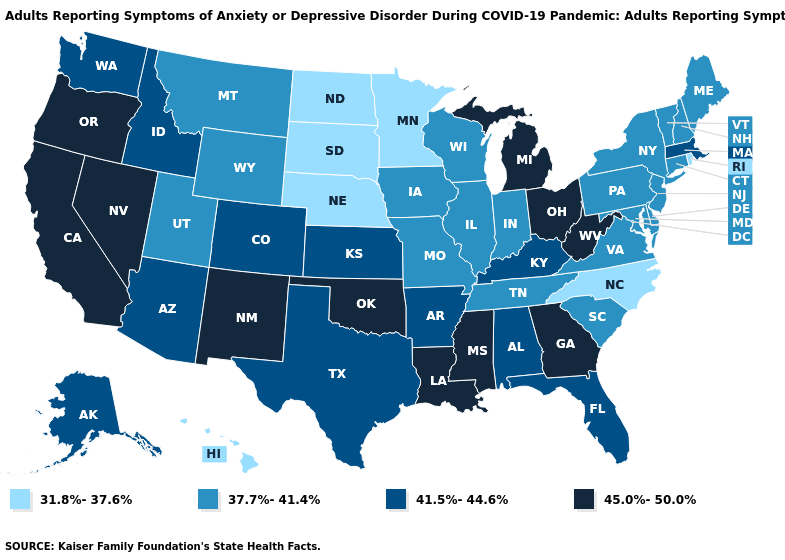Name the states that have a value in the range 45.0%-50.0%?
Answer briefly. California, Georgia, Louisiana, Michigan, Mississippi, Nevada, New Mexico, Ohio, Oklahoma, Oregon, West Virginia. Is the legend a continuous bar?
Write a very short answer. No. What is the value of New Mexico?
Answer briefly. 45.0%-50.0%. Does Maine have the highest value in the USA?
Concise answer only. No. Which states have the highest value in the USA?
Give a very brief answer. California, Georgia, Louisiana, Michigan, Mississippi, Nevada, New Mexico, Ohio, Oklahoma, Oregon, West Virginia. Does the first symbol in the legend represent the smallest category?
Keep it brief. Yes. How many symbols are there in the legend?
Short answer required. 4. What is the value of Maine?
Write a very short answer. 37.7%-41.4%. Name the states that have a value in the range 37.7%-41.4%?
Be succinct. Connecticut, Delaware, Illinois, Indiana, Iowa, Maine, Maryland, Missouri, Montana, New Hampshire, New Jersey, New York, Pennsylvania, South Carolina, Tennessee, Utah, Vermont, Virginia, Wisconsin, Wyoming. Does Nebraska have the lowest value in the USA?
Short answer required. Yes. Which states hav the highest value in the South?
Quick response, please. Georgia, Louisiana, Mississippi, Oklahoma, West Virginia. What is the value of Arizona?
Write a very short answer. 41.5%-44.6%. Does Georgia have the highest value in the South?
Quick response, please. Yes. Among the states that border Kentucky , which have the highest value?
Short answer required. Ohio, West Virginia. Which states have the lowest value in the MidWest?
Answer briefly. Minnesota, Nebraska, North Dakota, South Dakota. 